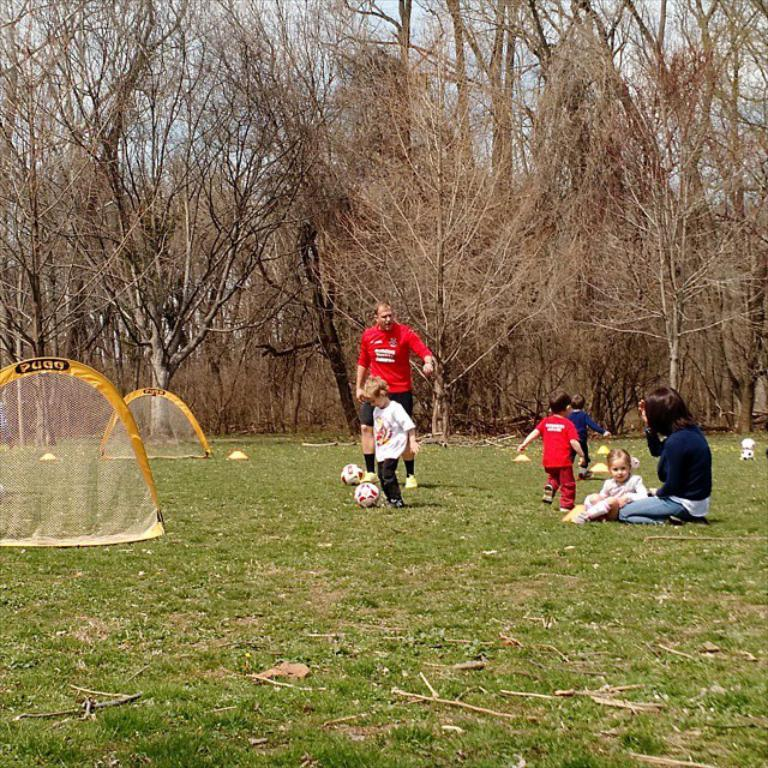What is the man in the image doing? There is a man standing in the image. What activity are the three boys engaged in? The three boys are playing with a ball in the image. What is the position of the woman in the image? There is a woman seated in the image. What is the position of the girl in the image? There is a girl seated in the image. What type of vegetation is visible in the image? Trees are visible in the image. What is the color of the grass in the image? There is green grass in the image. What type of van can be seen parked near the girl in the image? There is no van present in the image. Who is the uncle of the boys playing with the ball in the image? There is no mention of an uncle in the image or the provided facts. 